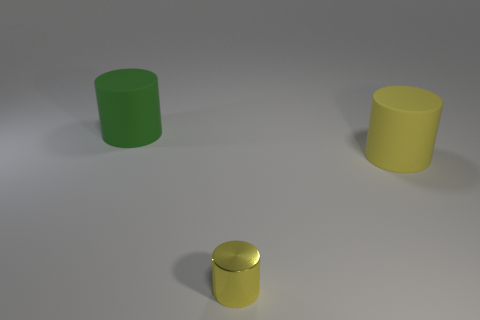Is there another large object that has the same color as the metallic object?
Make the answer very short. Yes. Is the green matte cylinder the same size as the yellow rubber object?
Offer a terse response. Yes. How big is the cylinder that is in front of the big cylinder that is in front of the large green rubber cylinder?
Offer a very short reply. Small. There is a cylinder that is both left of the big yellow matte cylinder and in front of the large green rubber cylinder; what is its size?
Keep it short and to the point. Small. What number of yellow shiny things have the same size as the green cylinder?
Provide a succinct answer. 0. How many metal things are big things or brown cylinders?
Provide a short and direct response. 0. The yellow cylinder on the left side of the rubber object that is in front of the large green rubber object is made of what material?
Make the answer very short. Metal. What number of things are either big green matte objects or rubber things to the left of the small yellow cylinder?
Make the answer very short. 1. The cylinder that is the same material as the large yellow object is what size?
Your answer should be very brief. Large. What number of blue things are small metal things or large rubber cylinders?
Offer a very short reply. 0. 